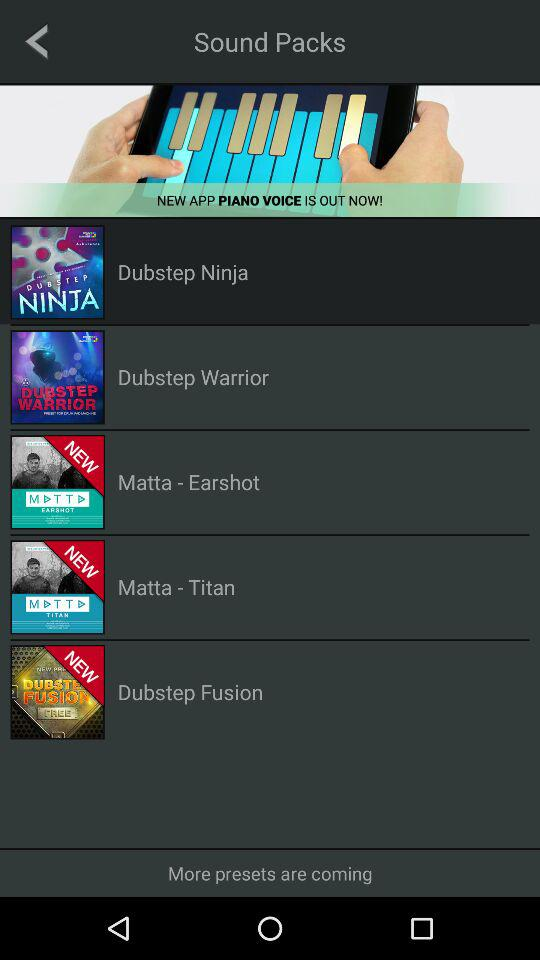What application is out now? The application "PIANO VOICE" is out now. 